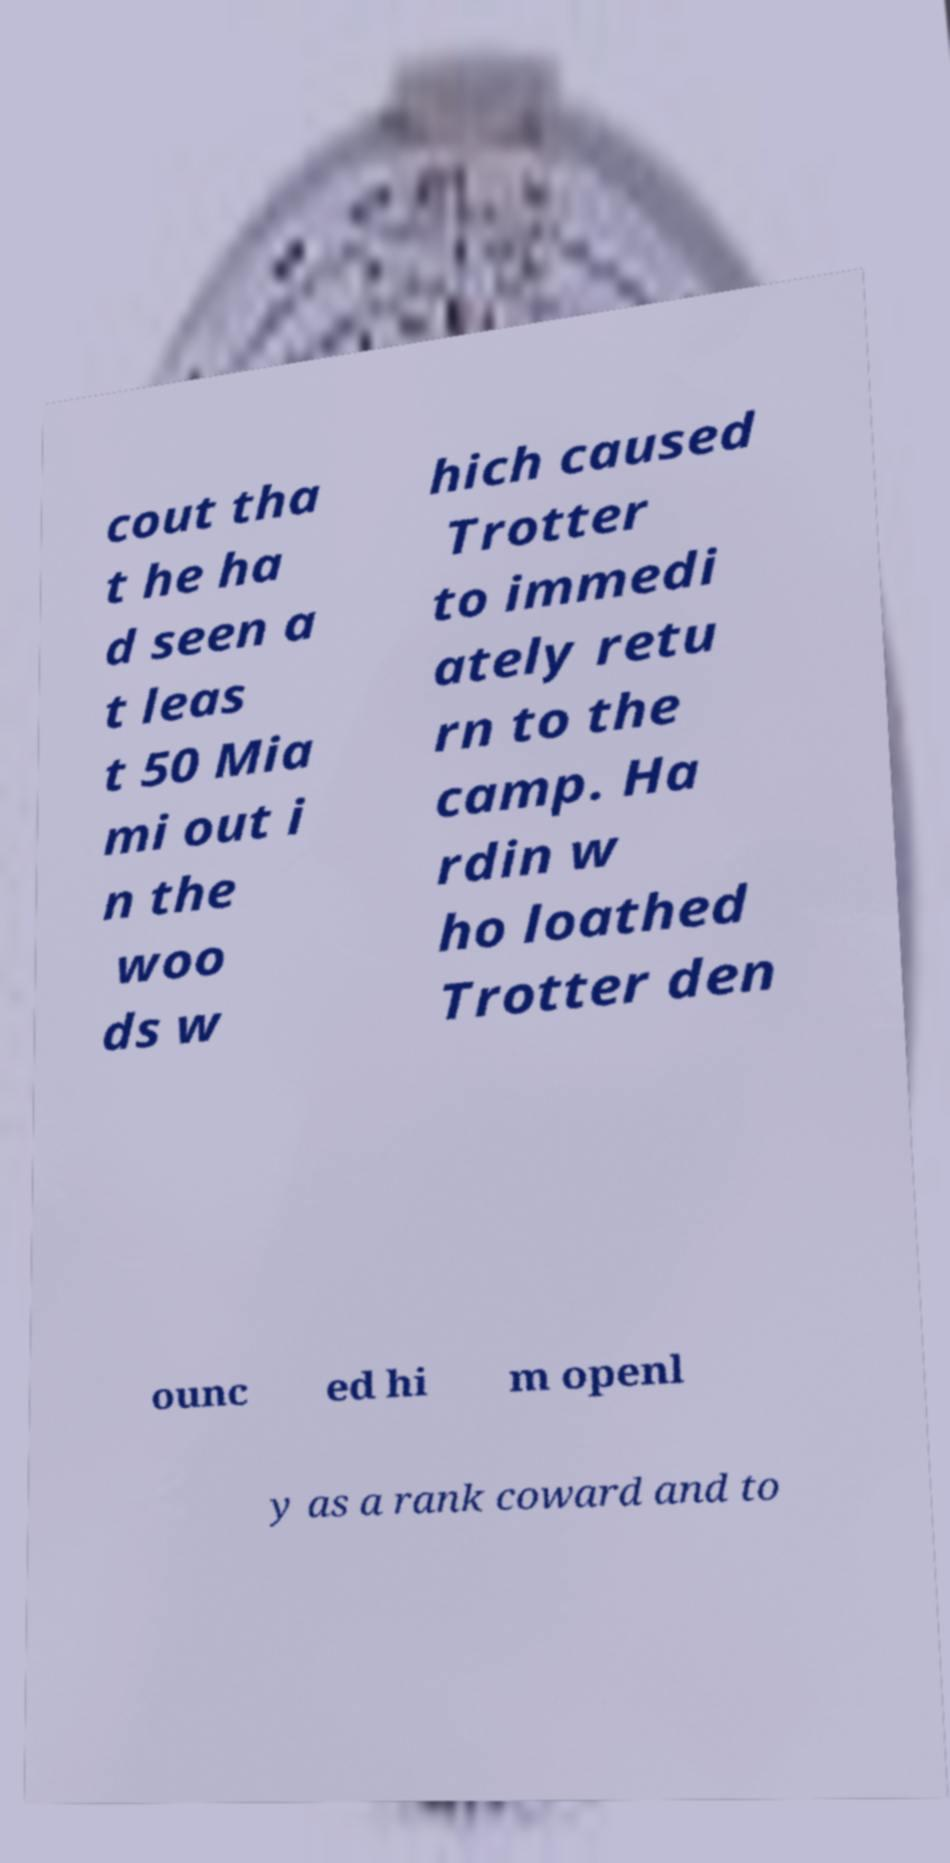There's text embedded in this image that I need extracted. Can you transcribe it verbatim? cout tha t he ha d seen a t leas t 50 Mia mi out i n the woo ds w hich caused Trotter to immedi ately retu rn to the camp. Ha rdin w ho loathed Trotter den ounc ed hi m openl y as a rank coward and to 